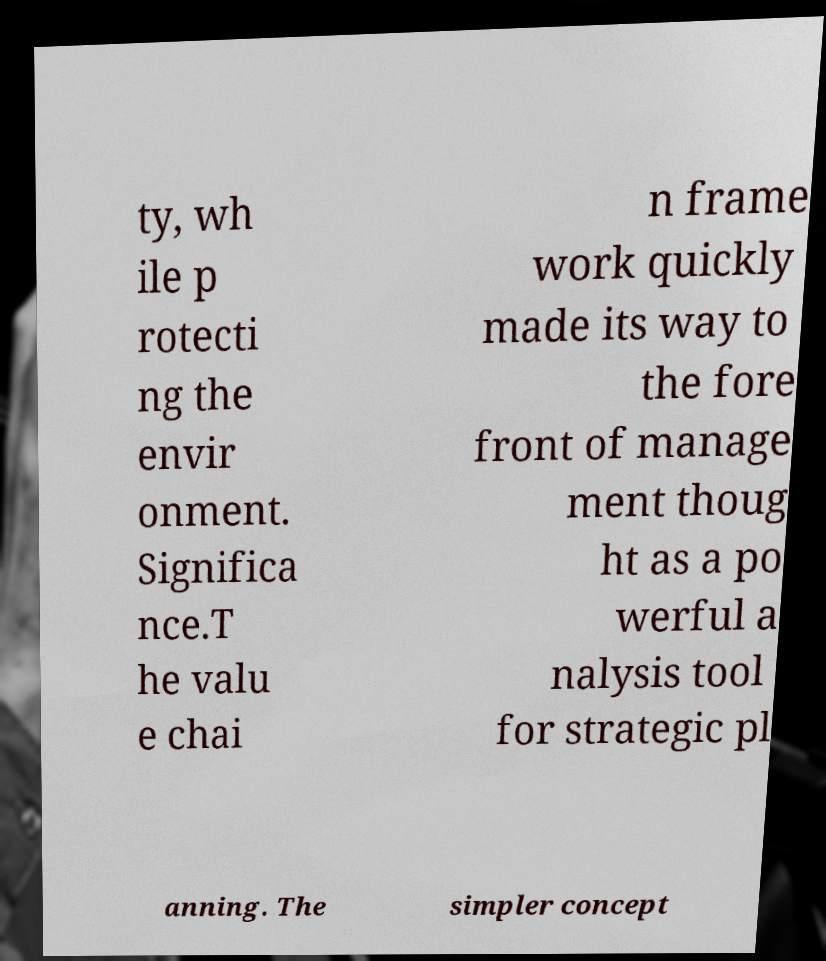For documentation purposes, I need the text within this image transcribed. Could you provide that? ty, wh ile p rotecti ng the envir onment. Significa nce.T he valu e chai n frame work quickly made its way to the fore front of manage ment thoug ht as a po werful a nalysis tool for strategic pl anning. The simpler concept 